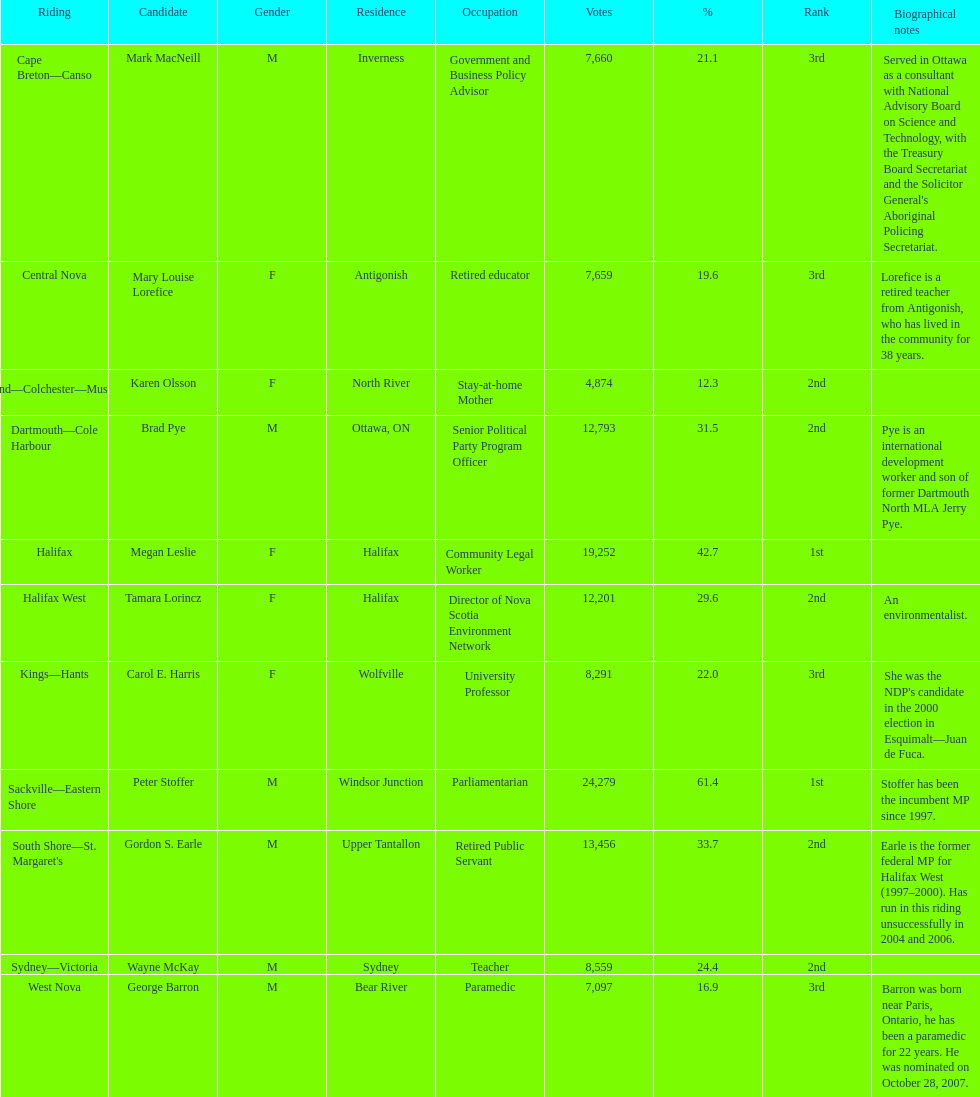How many candidates are there in total? 11. 